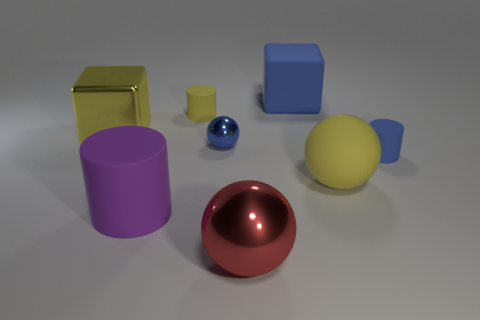Add 1 gray matte objects. How many objects exist? 9 Subtract all cubes. How many objects are left? 6 Subtract 1 yellow spheres. How many objects are left? 7 Subtract all large balls. Subtract all big matte cubes. How many objects are left? 5 Add 1 red metal spheres. How many red metal spheres are left? 2 Add 1 metal balls. How many metal balls exist? 3 